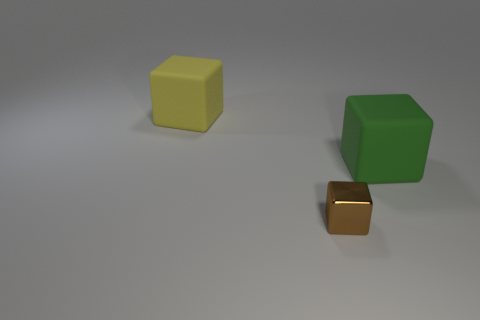What material is the big object in front of the large yellow block that is behind the tiny object?
Your answer should be compact. Rubber. Are there any big blocks that have the same material as the small object?
Give a very brief answer. No. Is there a yellow cube behind the object that is to the left of the small brown block?
Keep it short and to the point. No. What is the material of the thing that is in front of the green rubber block?
Offer a very short reply. Metal. Is the shape of the small brown metallic object the same as the yellow rubber thing?
Make the answer very short. Yes. There is a big matte block that is right of the cube in front of the matte object right of the tiny thing; what is its color?
Provide a succinct answer. Green. What number of big green things are the same shape as the tiny brown metallic object?
Your response must be concise. 1. How big is the rubber cube that is to the left of the big green thing that is on the right side of the metal thing?
Keep it short and to the point. Large. Does the brown metal thing have the same size as the green rubber block?
Give a very brief answer. No. There is a large rubber block that is in front of the large block on the left side of the metallic thing; are there any small brown metal blocks in front of it?
Give a very brief answer. Yes. 